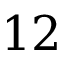Convert formula to latex. <formula><loc_0><loc_0><loc_500><loc_500>1 2</formula> 